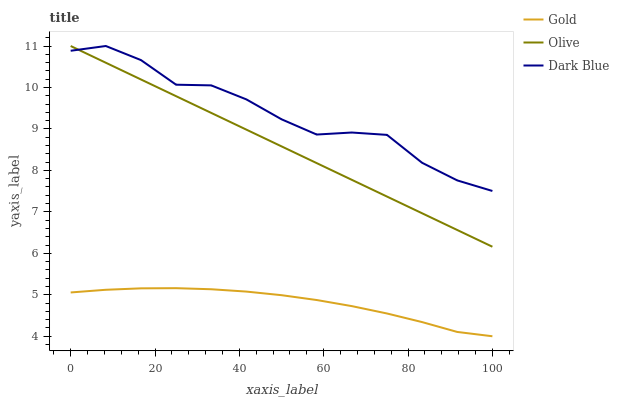Does Gold have the minimum area under the curve?
Answer yes or no. Yes. Does Dark Blue have the maximum area under the curve?
Answer yes or no. Yes. Does Dark Blue have the minimum area under the curve?
Answer yes or no. No. Does Gold have the maximum area under the curve?
Answer yes or no. No. Is Olive the smoothest?
Answer yes or no. Yes. Is Dark Blue the roughest?
Answer yes or no. Yes. Is Gold the smoothest?
Answer yes or no. No. Is Gold the roughest?
Answer yes or no. No. Does Gold have the lowest value?
Answer yes or no. Yes. Does Dark Blue have the lowest value?
Answer yes or no. No. Does Dark Blue have the highest value?
Answer yes or no. Yes. Does Gold have the highest value?
Answer yes or no. No. Is Gold less than Olive?
Answer yes or no. Yes. Is Dark Blue greater than Gold?
Answer yes or no. Yes. Does Dark Blue intersect Olive?
Answer yes or no. Yes. Is Dark Blue less than Olive?
Answer yes or no. No. Is Dark Blue greater than Olive?
Answer yes or no. No. Does Gold intersect Olive?
Answer yes or no. No. 